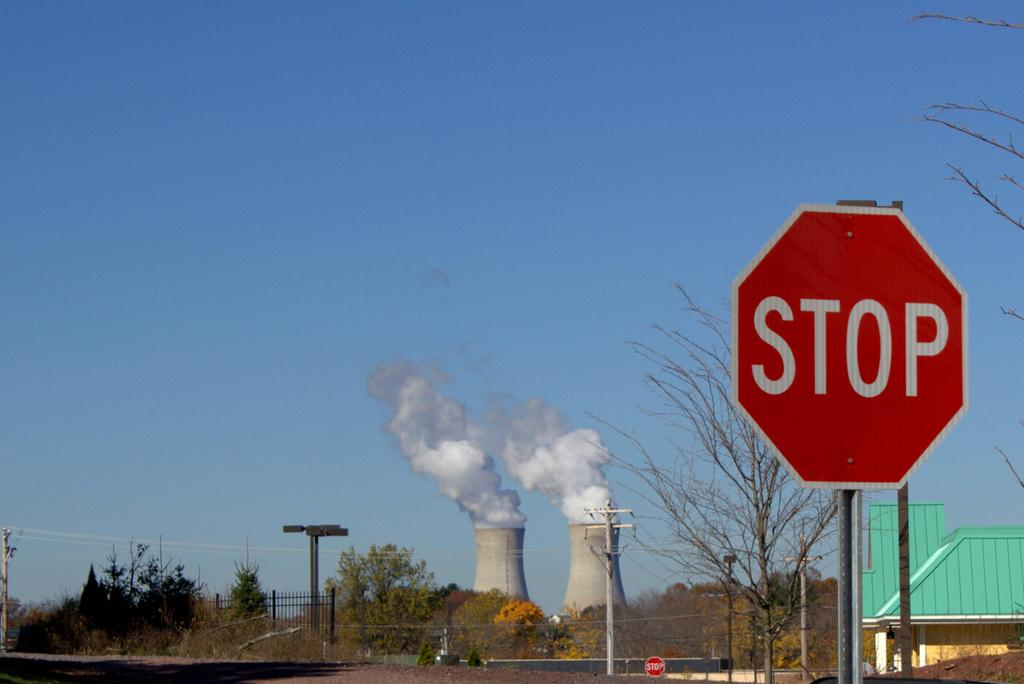<image>
Create a compact narrative representing the image presented. A red stop sign in front of some cooling towers. 